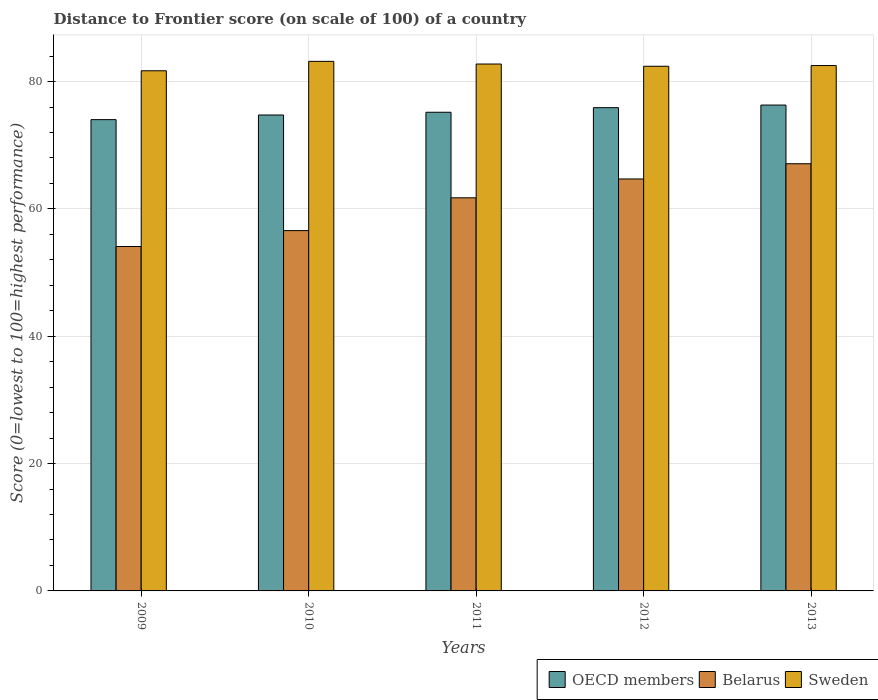How many different coloured bars are there?
Your response must be concise. 3. Are the number of bars per tick equal to the number of legend labels?
Offer a very short reply. Yes. How many bars are there on the 4th tick from the left?
Offer a terse response. 3. How many bars are there on the 4th tick from the right?
Give a very brief answer. 3. What is the distance to frontier score of in OECD members in 2012?
Offer a terse response. 75.9. Across all years, what is the maximum distance to frontier score of in Sweden?
Your answer should be compact. 83.17. Across all years, what is the minimum distance to frontier score of in Sweden?
Ensure brevity in your answer.  81.69. In which year was the distance to frontier score of in Sweden maximum?
Your answer should be compact. 2010. What is the total distance to frontier score of in Belarus in the graph?
Give a very brief answer. 304.21. What is the difference between the distance to frontier score of in OECD members in 2009 and that in 2011?
Your answer should be very brief. -1.16. What is the difference between the distance to frontier score of in Sweden in 2011 and the distance to frontier score of in OECD members in 2012?
Your answer should be compact. 6.85. What is the average distance to frontier score of in OECD members per year?
Make the answer very short. 75.23. In the year 2012, what is the difference between the distance to frontier score of in OECD members and distance to frontier score of in Belarus?
Provide a short and direct response. 11.2. What is the ratio of the distance to frontier score of in Belarus in 2011 to that in 2013?
Ensure brevity in your answer.  0.92. Is the difference between the distance to frontier score of in OECD members in 2010 and 2012 greater than the difference between the distance to frontier score of in Belarus in 2010 and 2012?
Make the answer very short. Yes. What is the difference between the highest and the second highest distance to frontier score of in OECD members?
Make the answer very short. 0.41. In how many years, is the distance to frontier score of in OECD members greater than the average distance to frontier score of in OECD members taken over all years?
Provide a short and direct response. 2. What does the 2nd bar from the right in 2010 represents?
Provide a short and direct response. Belarus. Is it the case that in every year, the sum of the distance to frontier score of in OECD members and distance to frontier score of in Sweden is greater than the distance to frontier score of in Belarus?
Make the answer very short. Yes. How many bars are there?
Your answer should be compact. 15. Does the graph contain any zero values?
Your response must be concise. No. How many legend labels are there?
Your answer should be compact. 3. What is the title of the graph?
Your response must be concise. Distance to Frontier score (on scale of 100) of a country. What is the label or title of the X-axis?
Offer a terse response. Years. What is the label or title of the Y-axis?
Your response must be concise. Score (0=lowest to 100=highest performance). What is the Score (0=lowest to 100=highest performance) in OECD members in 2009?
Make the answer very short. 74.02. What is the Score (0=lowest to 100=highest performance) in Belarus in 2009?
Make the answer very short. 54.09. What is the Score (0=lowest to 100=highest performance) of Sweden in 2009?
Your answer should be very brief. 81.69. What is the Score (0=lowest to 100=highest performance) of OECD members in 2010?
Your response must be concise. 74.74. What is the Score (0=lowest to 100=highest performance) in Belarus in 2010?
Provide a succinct answer. 56.59. What is the Score (0=lowest to 100=highest performance) in Sweden in 2010?
Provide a succinct answer. 83.17. What is the Score (0=lowest to 100=highest performance) of OECD members in 2011?
Give a very brief answer. 75.18. What is the Score (0=lowest to 100=highest performance) of Belarus in 2011?
Offer a very short reply. 61.74. What is the Score (0=lowest to 100=highest performance) in Sweden in 2011?
Keep it short and to the point. 82.75. What is the Score (0=lowest to 100=highest performance) in OECD members in 2012?
Provide a succinct answer. 75.9. What is the Score (0=lowest to 100=highest performance) in Belarus in 2012?
Offer a terse response. 64.7. What is the Score (0=lowest to 100=highest performance) in Sweden in 2012?
Provide a short and direct response. 82.4. What is the Score (0=lowest to 100=highest performance) in OECD members in 2013?
Give a very brief answer. 76.31. What is the Score (0=lowest to 100=highest performance) in Belarus in 2013?
Provide a succinct answer. 67.09. What is the Score (0=lowest to 100=highest performance) in Sweden in 2013?
Give a very brief answer. 82.51. Across all years, what is the maximum Score (0=lowest to 100=highest performance) of OECD members?
Keep it short and to the point. 76.31. Across all years, what is the maximum Score (0=lowest to 100=highest performance) of Belarus?
Make the answer very short. 67.09. Across all years, what is the maximum Score (0=lowest to 100=highest performance) of Sweden?
Offer a terse response. 83.17. Across all years, what is the minimum Score (0=lowest to 100=highest performance) of OECD members?
Your response must be concise. 74.02. Across all years, what is the minimum Score (0=lowest to 100=highest performance) in Belarus?
Provide a short and direct response. 54.09. Across all years, what is the minimum Score (0=lowest to 100=highest performance) of Sweden?
Offer a very short reply. 81.69. What is the total Score (0=lowest to 100=highest performance) in OECD members in the graph?
Your response must be concise. 376.14. What is the total Score (0=lowest to 100=highest performance) of Belarus in the graph?
Your answer should be very brief. 304.21. What is the total Score (0=lowest to 100=highest performance) of Sweden in the graph?
Keep it short and to the point. 412.52. What is the difference between the Score (0=lowest to 100=highest performance) of OECD members in 2009 and that in 2010?
Provide a short and direct response. -0.73. What is the difference between the Score (0=lowest to 100=highest performance) in Belarus in 2009 and that in 2010?
Provide a short and direct response. -2.5. What is the difference between the Score (0=lowest to 100=highest performance) of Sweden in 2009 and that in 2010?
Provide a short and direct response. -1.48. What is the difference between the Score (0=lowest to 100=highest performance) of OECD members in 2009 and that in 2011?
Make the answer very short. -1.16. What is the difference between the Score (0=lowest to 100=highest performance) of Belarus in 2009 and that in 2011?
Keep it short and to the point. -7.65. What is the difference between the Score (0=lowest to 100=highest performance) of Sweden in 2009 and that in 2011?
Give a very brief answer. -1.06. What is the difference between the Score (0=lowest to 100=highest performance) in OECD members in 2009 and that in 2012?
Offer a terse response. -1.88. What is the difference between the Score (0=lowest to 100=highest performance) of Belarus in 2009 and that in 2012?
Your response must be concise. -10.61. What is the difference between the Score (0=lowest to 100=highest performance) of Sweden in 2009 and that in 2012?
Provide a short and direct response. -0.71. What is the difference between the Score (0=lowest to 100=highest performance) of OECD members in 2009 and that in 2013?
Your response must be concise. -2.29. What is the difference between the Score (0=lowest to 100=highest performance) of Sweden in 2009 and that in 2013?
Keep it short and to the point. -0.82. What is the difference between the Score (0=lowest to 100=highest performance) of OECD members in 2010 and that in 2011?
Provide a short and direct response. -0.43. What is the difference between the Score (0=lowest to 100=highest performance) of Belarus in 2010 and that in 2011?
Give a very brief answer. -5.15. What is the difference between the Score (0=lowest to 100=highest performance) of Sweden in 2010 and that in 2011?
Ensure brevity in your answer.  0.42. What is the difference between the Score (0=lowest to 100=highest performance) in OECD members in 2010 and that in 2012?
Provide a succinct answer. -1.15. What is the difference between the Score (0=lowest to 100=highest performance) in Belarus in 2010 and that in 2012?
Your response must be concise. -8.11. What is the difference between the Score (0=lowest to 100=highest performance) of Sweden in 2010 and that in 2012?
Give a very brief answer. 0.77. What is the difference between the Score (0=lowest to 100=highest performance) of OECD members in 2010 and that in 2013?
Provide a succinct answer. -1.56. What is the difference between the Score (0=lowest to 100=highest performance) in Sweden in 2010 and that in 2013?
Keep it short and to the point. 0.66. What is the difference between the Score (0=lowest to 100=highest performance) in OECD members in 2011 and that in 2012?
Offer a terse response. -0.72. What is the difference between the Score (0=lowest to 100=highest performance) of Belarus in 2011 and that in 2012?
Offer a terse response. -2.96. What is the difference between the Score (0=lowest to 100=highest performance) of OECD members in 2011 and that in 2013?
Your response must be concise. -1.13. What is the difference between the Score (0=lowest to 100=highest performance) of Belarus in 2011 and that in 2013?
Ensure brevity in your answer.  -5.35. What is the difference between the Score (0=lowest to 100=highest performance) in Sweden in 2011 and that in 2013?
Offer a very short reply. 0.24. What is the difference between the Score (0=lowest to 100=highest performance) in OECD members in 2012 and that in 2013?
Your response must be concise. -0.41. What is the difference between the Score (0=lowest to 100=highest performance) of Belarus in 2012 and that in 2013?
Give a very brief answer. -2.39. What is the difference between the Score (0=lowest to 100=highest performance) in Sweden in 2012 and that in 2013?
Offer a very short reply. -0.11. What is the difference between the Score (0=lowest to 100=highest performance) in OECD members in 2009 and the Score (0=lowest to 100=highest performance) in Belarus in 2010?
Your answer should be very brief. 17.43. What is the difference between the Score (0=lowest to 100=highest performance) in OECD members in 2009 and the Score (0=lowest to 100=highest performance) in Sweden in 2010?
Make the answer very short. -9.15. What is the difference between the Score (0=lowest to 100=highest performance) in Belarus in 2009 and the Score (0=lowest to 100=highest performance) in Sweden in 2010?
Offer a very short reply. -29.08. What is the difference between the Score (0=lowest to 100=highest performance) of OECD members in 2009 and the Score (0=lowest to 100=highest performance) of Belarus in 2011?
Provide a succinct answer. 12.28. What is the difference between the Score (0=lowest to 100=highest performance) in OECD members in 2009 and the Score (0=lowest to 100=highest performance) in Sweden in 2011?
Offer a terse response. -8.73. What is the difference between the Score (0=lowest to 100=highest performance) in Belarus in 2009 and the Score (0=lowest to 100=highest performance) in Sweden in 2011?
Keep it short and to the point. -28.66. What is the difference between the Score (0=lowest to 100=highest performance) in OECD members in 2009 and the Score (0=lowest to 100=highest performance) in Belarus in 2012?
Your response must be concise. 9.32. What is the difference between the Score (0=lowest to 100=highest performance) of OECD members in 2009 and the Score (0=lowest to 100=highest performance) of Sweden in 2012?
Provide a succinct answer. -8.38. What is the difference between the Score (0=lowest to 100=highest performance) of Belarus in 2009 and the Score (0=lowest to 100=highest performance) of Sweden in 2012?
Your answer should be very brief. -28.31. What is the difference between the Score (0=lowest to 100=highest performance) in OECD members in 2009 and the Score (0=lowest to 100=highest performance) in Belarus in 2013?
Offer a terse response. 6.93. What is the difference between the Score (0=lowest to 100=highest performance) in OECD members in 2009 and the Score (0=lowest to 100=highest performance) in Sweden in 2013?
Your answer should be very brief. -8.49. What is the difference between the Score (0=lowest to 100=highest performance) in Belarus in 2009 and the Score (0=lowest to 100=highest performance) in Sweden in 2013?
Your answer should be compact. -28.42. What is the difference between the Score (0=lowest to 100=highest performance) of OECD members in 2010 and the Score (0=lowest to 100=highest performance) of Belarus in 2011?
Your answer should be compact. 13. What is the difference between the Score (0=lowest to 100=highest performance) of OECD members in 2010 and the Score (0=lowest to 100=highest performance) of Sweden in 2011?
Give a very brief answer. -8.01. What is the difference between the Score (0=lowest to 100=highest performance) in Belarus in 2010 and the Score (0=lowest to 100=highest performance) in Sweden in 2011?
Provide a short and direct response. -26.16. What is the difference between the Score (0=lowest to 100=highest performance) of OECD members in 2010 and the Score (0=lowest to 100=highest performance) of Belarus in 2012?
Your answer should be compact. 10.04. What is the difference between the Score (0=lowest to 100=highest performance) in OECD members in 2010 and the Score (0=lowest to 100=highest performance) in Sweden in 2012?
Your response must be concise. -7.66. What is the difference between the Score (0=lowest to 100=highest performance) in Belarus in 2010 and the Score (0=lowest to 100=highest performance) in Sweden in 2012?
Ensure brevity in your answer.  -25.81. What is the difference between the Score (0=lowest to 100=highest performance) in OECD members in 2010 and the Score (0=lowest to 100=highest performance) in Belarus in 2013?
Your answer should be very brief. 7.65. What is the difference between the Score (0=lowest to 100=highest performance) in OECD members in 2010 and the Score (0=lowest to 100=highest performance) in Sweden in 2013?
Your answer should be very brief. -7.77. What is the difference between the Score (0=lowest to 100=highest performance) of Belarus in 2010 and the Score (0=lowest to 100=highest performance) of Sweden in 2013?
Offer a very short reply. -25.92. What is the difference between the Score (0=lowest to 100=highest performance) in OECD members in 2011 and the Score (0=lowest to 100=highest performance) in Belarus in 2012?
Ensure brevity in your answer.  10.48. What is the difference between the Score (0=lowest to 100=highest performance) of OECD members in 2011 and the Score (0=lowest to 100=highest performance) of Sweden in 2012?
Offer a very short reply. -7.22. What is the difference between the Score (0=lowest to 100=highest performance) of Belarus in 2011 and the Score (0=lowest to 100=highest performance) of Sweden in 2012?
Your answer should be compact. -20.66. What is the difference between the Score (0=lowest to 100=highest performance) in OECD members in 2011 and the Score (0=lowest to 100=highest performance) in Belarus in 2013?
Make the answer very short. 8.09. What is the difference between the Score (0=lowest to 100=highest performance) in OECD members in 2011 and the Score (0=lowest to 100=highest performance) in Sweden in 2013?
Offer a very short reply. -7.33. What is the difference between the Score (0=lowest to 100=highest performance) of Belarus in 2011 and the Score (0=lowest to 100=highest performance) of Sweden in 2013?
Ensure brevity in your answer.  -20.77. What is the difference between the Score (0=lowest to 100=highest performance) in OECD members in 2012 and the Score (0=lowest to 100=highest performance) in Belarus in 2013?
Your answer should be compact. 8.81. What is the difference between the Score (0=lowest to 100=highest performance) of OECD members in 2012 and the Score (0=lowest to 100=highest performance) of Sweden in 2013?
Ensure brevity in your answer.  -6.61. What is the difference between the Score (0=lowest to 100=highest performance) of Belarus in 2012 and the Score (0=lowest to 100=highest performance) of Sweden in 2013?
Your answer should be compact. -17.81. What is the average Score (0=lowest to 100=highest performance) in OECD members per year?
Make the answer very short. 75.23. What is the average Score (0=lowest to 100=highest performance) in Belarus per year?
Your response must be concise. 60.84. What is the average Score (0=lowest to 100=highest performance) of Sweden per year?
Give a very brief answer. 82.5. In the year 2009, what is the difference between the Score (0=lowest to 100=highest performance) in OECD members and Score (0=lowest to 100=highest performance) in Belarus?
Ensure brevity in your answer.  19.93. In the year 2009, what is the difference between the Score (0=lowest to 100=highest performance) of OECD members and Score (0=lowest to 100=highest performance) of Sweden?
Offer a terse response. -7.67. In the year 2009, what is the difference between the Score (0=lowest to 100=highest performance) of Belarus and Score (0=lowest to 100=highest performance) of Sweden?
Make the answer very short. -27.6. In the year 2010, what is the difference between the Score (0=lowest to 100=highest performance) of OECD members and Score (0=lowest to 100=highest performance) of Belarus?
Offer a terse response. 18.15. In the year 2010, what is the difference between the Score (0=lowest to 100=highest performance) of OECD members and Score (0=lowest to 100=highest performance) of Sweden?
Provide a succinct answer. -8.43. In the year 2010, what is the difference between the Score (0=lowest to 100=highest performance) in Belarus and Score (0=lowest to 100=highest performance) in Sweden?
Your answer should be very brief. -26.58. In the year 2011, what is the difference between the Score (0=lowest to 100=highest performance) of OECD members and Score (0=lowest to 100=highest performance) of Belarus?
Keep it short and to the point. 13.44. In the year 2011, what is the difference between the Score (0=lowest to 100=highest performance) of OECD members and Score (0=lowest to 100=highest performance) of Sweden?
Your answer should be very brief. -7.57. In the year 2011, what is the difference between the Score (0=lowest to 100=highest performance) of Belarus and Score (0=lowest to 100=highest performance) of Sweden?
Keep it short and to the point. -21.01. In the year 2012, what is the difference between the Score (0=lowest to 100=highest performance) of OECD members and Score (0=lowest to 100=highest performance) of Belarus?
Your answer should be compact. 11.2. In the year 2012, what is the difference between the Score (0=lowest to 100=highest performance) in OECD members and Score (0=lowest to 100=highest performance) in Sweden?
Your answer should be very brief. -6.5. In the year 2012, what is the difference between the Score (0=lowest to 100=highest performance) of Belarus and Score (0=lowest to 100=highest performance) of Sweden?
Keep it short and to the point. -17.7. In the year 2013, what is the difference between the Score (0=lowest to 100=highest performance) in OECD members and Score (0=lowest to 100=highest performance) in Belarus?
Make the answer very short. 9.22. In the year 2013, what is the difference between the Score (0=lowest to 100=highest performance) in OECD members and Score (0=lowest to 100=highest performance) in Sweden?
Offer a very short reply. -6.2. In the year 2013, what is the difference between the Score (0=lowest to 100=highest performance) of Belarus and Score (0=lowest to 100=highest performance) of Sweden?
Make the answer very short. -15.42. What is the ratio of the Score (0=lowest to 100=highest performance) of OECD members in 2009 to that in 2010?
Your answer should be compact. 0.99. What is the ratio of the Score (0=lowest to 100=highest performance) in Belarus in 2009 to that in 2010?
Your answer should be very brief. 0.96. What is the ratio of the Score (0=lowest to 100=highest performance) in Sweden in 2009 to that in 2010?
Offer a very short reply. 0.98. What is the ratio of the Score (0=lowest to 100=highest performance) of OECD members in 2009 to that in 2011?
Offer a terse response. 0.98. What is the ratio of the Score (0=lowest to 100=highest performance) in Belarus in 2009 to that in 2011?
Your answer should be compact. 0.88. What is the ratio of the Score (0=lowest to 100=highest performance) of Sweden in 2009 to that in 2011?
Give a very brief answer. 0.99. What is the ratio of the Score (0=lowest to 100=highest performance) of OECD members in 2009 to that in 2012?
Ensure brevity in your answer.  0.98. What is the ratio of the Score (0=lowest to 100=highest performance) of Belarus in 2009 to that in 2012?
Your answer should be very brief. 0.84. What is the ratio of the Score (0=lowest to 100=highest performance) in Belarus in 2009 to that in 2013?
Provide a short and direct response. 0.81. What is the ratio of the Score (0=lowest to 100=highest performance) in Sweden in 2009 to that in 2013?
Provide a short and direct response. 0.99. What is the ratio of the Score (0=lowest to 100=highest performance) in Belarus in 2010 to that in 2011?
Your answer should be compact. 0.92. What is the ratio of the Score (0=lowest to 100=highest performance) in Sweden in 2010 to that in 2011?
Your answer should be compact. 1.01. What is the ratio of the Score (0=lowest to 100=highest performance) in OECD members in 2010 to that in 2012?
Make the answer very short. 0.98. What is the ratio of the Score (0=lowest to 100=highest performance) of Belarus in 2010 to that in 2012?
Your response must be concise. 0.87. What is the ratio of the Score (0=lowest to 100=highest performance) of Sweden in 2010 to that in 2012?
Keep it short and to the point. 1.01. What is the ratio of the Score (0=lowest to 100=highest performance) of OECD members in 2010 to that in 2013?
Provide a succinct answer. 0.98. What is the ratio of the Score (0=lowest to 100=highest performance) of Belarus in 2010 to that in 2013?
Your response must be concise. 0.84. What is the ratio of the Score (0=lowest to 100=highest performance) in OECD members in 2011 to that in 2012?
Provide a succinct answer. 0.99. What is the ratio of the Score (0=lowest to 100=highest performance) in Belarus in 2011 to that in 2012?
Your answer should be very brief. 0.95. What is the ratio of the Score (0=lowest to 100=highest performance) of Sweden in 2011 to that in 2012?
Provide a short and direct response. 1. What is the ratio of the Score (0=lowest to 100=highest performance) in OECD members in 2011 to that in 2013?
Give a very brief answer. 0.99. What is the ratio of the Score (0=lowest to 100=highest performance) in Belarus in 2011 to that in 2013?
Provide a short and direct response. 0.92. What is the ratio of the Score (0=lowest to 100=highest performance) in Sweden in 2011 to that in 2013?
Offer a very short reply. 1. What is the ratio of the Score (0=lowest to 100=highest performance) of OECD members in 2012 to that in 2013?
Your answer should be compact. 0.99. What is the ratio of the Score (0=lowest to 100=highest performance) of Belarus in 2012 to that in 2013?
Give a very brief answer. 0.96. What is the ratio of the Score (0=lowest to 100=highest performance) in Sweden in 2012 to that in 2013?
Provide a short and direct response. 1. What is the difference between the highest and the second highest Score (0=lowest to 100=highest performance) in OECD members?
Keep it short and to the point. 0.41. What is the difference between the highest and the second highest Score (0=lowest to 100=highest performance) of Belarus?
Ensure brevity in your answer.  2.39. What is the difference between the highest and the second highest Score (0=lowest to 100=highest performance) in Sweden?
Provide a succinct answer. 0.42. What is the difference between the highest and the lowest Score (0=lowest to 100=highest performance) of OECD members?
Make the answer very short. 2.29. What is the difference between the highest and the lowest Score (0=lowest to 100=highest performance) in Belarus?
Provide a short and direct response. 13. What is the difference between the highest and the lowest Score (0=lowest to 100=highest performance) in Sweden?
Ensure brevity in your answer.  1.48. 